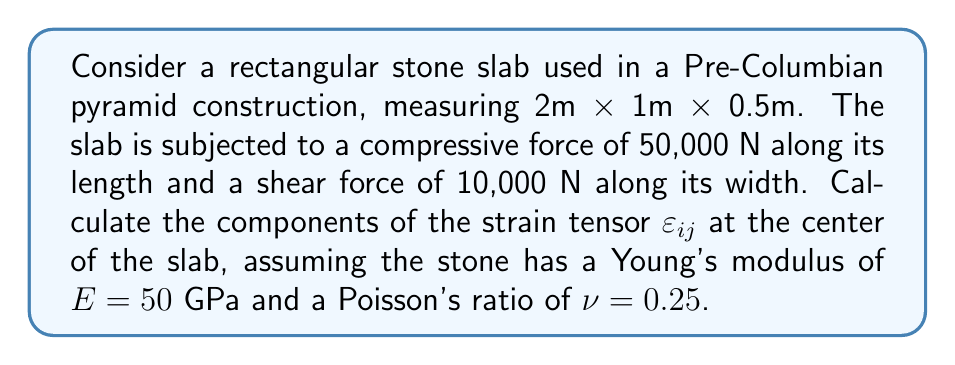Provide a solution to this math problem. To solve this problem, we'll follow these steps:

1) First, let's define our coordinate system:
   x-axis: along the length (2m)
   y-axis: along the width (1m)
   z-axis: along the height (0.5m)

2) Calculate the stresses:
   Normal stress: $\sigma_{xx} = \frac{F}{A} = \frac{50,000 \text{ N}}{1 \text{ m} \times 0.5 \text{ m}} = 100,000 \text{ Pa}$
   Shear stress: $\tau_{xy} = \frac{F}{A} = \frac{10,000 \text{ N}}{2 \text{ m} \times 0.5 \text{ m}} = 10,000 \text{ Pa}$

3) For an isotropic material, the strain tensor is related to the stress tensor by:

   $$\varepsilon_{ij} = \frac{1}{E}[(1+\nu)\sigma_{ij} - \nu\sigma_{kk}\delta_{ij}]$$

   where $\delta_{ij}$ is the Kronecker delta.

4) Calculate the components:

   $\varepsilon_{xx} = \frac{1}{E}[\sigma_{xx} - \nu(\sigma_{xx} + \sigma_{yy} + \sigma_{zz})] = \frac{1}{50 \times 10^9}[100,000 - 0.25(100,000)] = 1.5 \times 10^{-6}$

   $\varepsilon_{yy} = \varepsilon_{zz} = -\frac{\nu}{E}\sigma_{xx} = -\frac{0.25}{50 \times 10^9} \times 100,000 = -0.5 \times 10^{-6}$

   $\varepsilon_{xy} = \varepsilon_{yx} = \frac{1+\nu}{E}\tau_{xy} = \frac{1.25}{50 \times 10^9} \times 10,000 = 0.25 \times 10^{-6}$

   $\varepsilon_{yz} = \varepsilon_{zx} = 0$ (no shear in these planes)

5) The strain tensor is thus:

   $$\varepsilon_{ij} = \begin{pmatrix}
   1.5 & 0.25 & 0 \\
   0.25 & -0.5 & 0 \\
   0 & 0 & -0.5
   \end{pmatrix} \times 10^{-6}$$
Answer: $\varepsilon_{ij} = \begin{pmatrix}
1.5 & 0.25 & 0 \\
0.25 & -0.5 & 0 \\
0 & 0 & -0.5
\end{pmatrix} \times 10^{-6}$ 